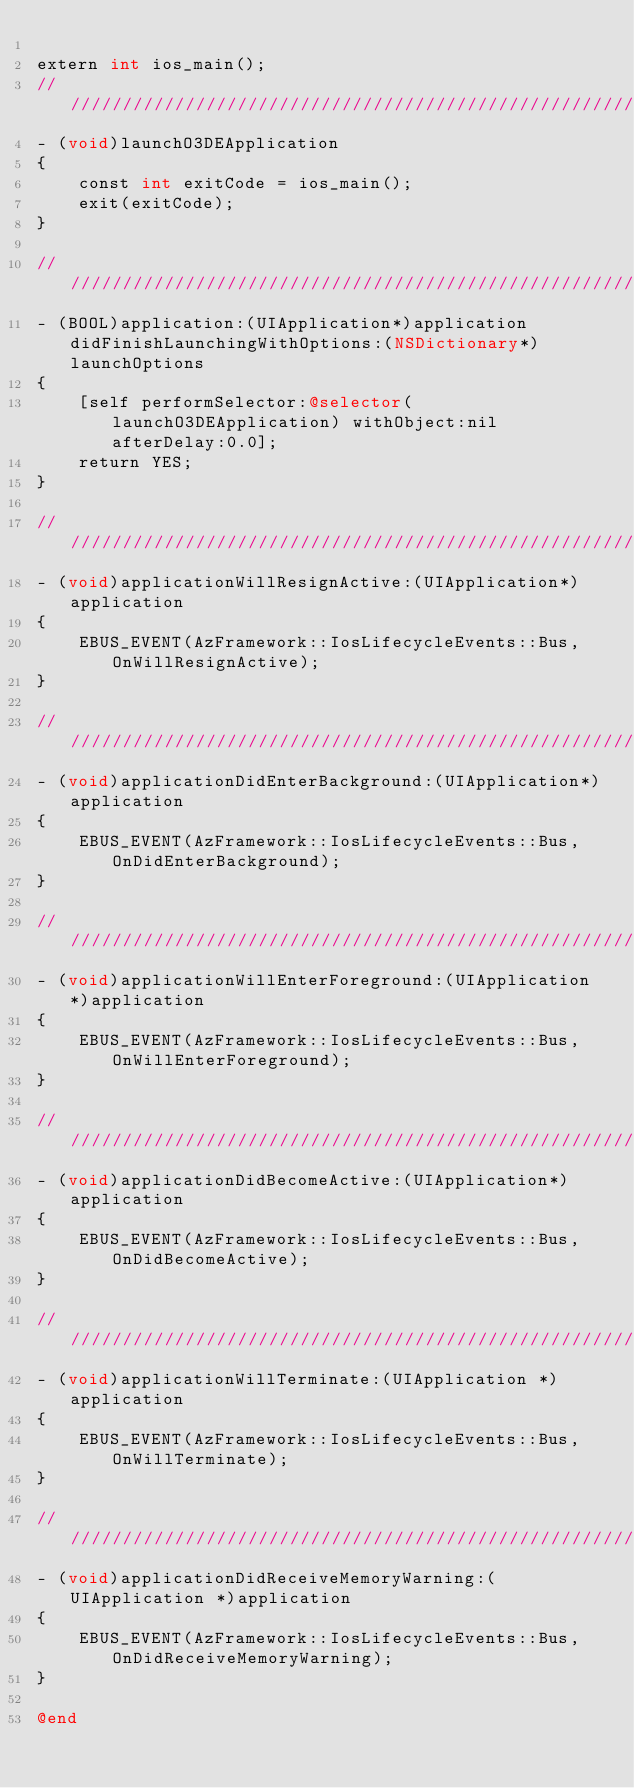Convert code to text. <code><loc_0><loc_0><loc_500><loc_500><_ObjectiveC_>
extern int ios_main();
////////////////////////////////////////////////////////////////////////////////////////////////////
- (void)launchO3DEApplication
{
    const int exitCode = ios_main();
    exit(exitCode);
}

////////////////////////////////////////////////////////////////////////////////////////////////////
- (BOOL)application:(UIApplication*)application didFinishLaunchingWithOptions:(NSDictionary*)launchOptions
{
    [self performSelector:@selector(launchO3DEApplication) withObject:nil afterDelay:0.0];
    return YES;
}

////////////////////////////////////////////////////////////////////////////////////////////////////
- (void)applicationWillResignActive:(UIApplication*)application
{
    EBUS_EVENT(AzFramework::IosLifecycleEvents::Bus, OnWillResignActive);
}

////////////////////////////////////////////////////////////////////////////////////////////////////
- (void)applicationDidEnterBackground:(UIApplication*)application
{
    EBUS_EVENT(AzFramework::IosLifecycleEvents::Bus, OnDidEnterBackground);
}

////////////////////////////////////////////////////////////////////////////////////////////////////
- (void)applicationWillEnterForeground:(UIApplication*)application
{
    EBUS_EVENT(AzFramework::IosLifecycleEvents::Bus, OnWillEnterForeground);
}

////////////////////////////////////////////////////////////////////////////////////////////////////
- (void)applicationDidBecomeActive:(UIApplication*)application
{
    EBUS_EVENT(AzFramework::IosLifecycleEvents::Bus, OnDidBecomeActive);
}

////////////////////////////////////////////////////////////////////////////////////////////////////
- (void)applicationWillTerminate:(UIApplication *)application
{
    EBUS_EVENT(AzFramework::IosLifecycleEvents::Bus, OnWillTerminate);
}

////////////////////////////////////////////////////////////////////////////////////////////////////
- (void)applicationDidReceiveMemoryWarning:(UIApplication *)application
{
    EBUS_EVENT(AzFramework::IosLifecycleEvents::Bus, OnDidReceiveMemoryWarning);
}

@end 
</code> 